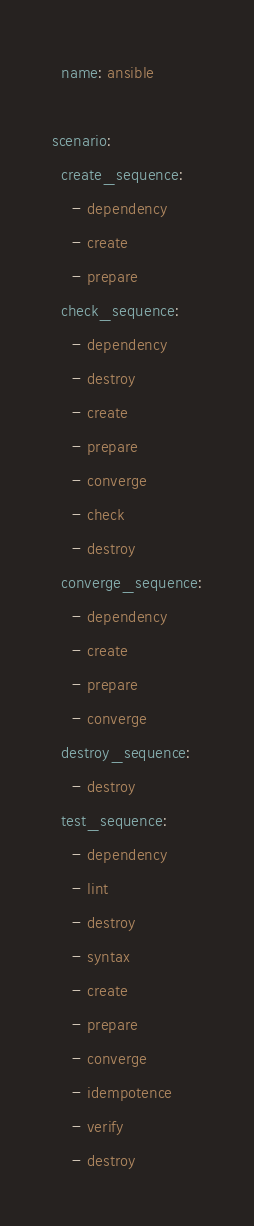<code> <loc_0><loc_0><loc_500><loc_500><_YAML_>  name: ansible

scenario:
  create_sequence:
    - dependency
    - create
    - prepare
  check_sequence:
    - dependency
    - destroy
    - create
    - prepare
    - converge
    - check
    - destroy
  converge_sequence:
    - dependency
    - create
    - prepare
    - converge
  destroy_sequence:
    - destroy
  test_sequence:
    - dependency
    - lint
    - destroy
    - syntax
    - create
    - prepare
    - converge
    - idempotence
    - verify
    - destroy
</code> 